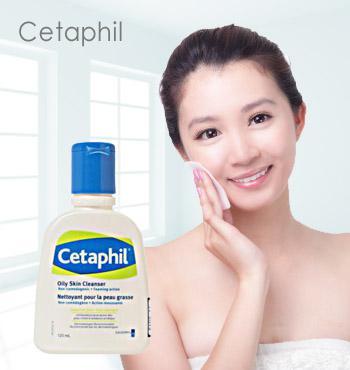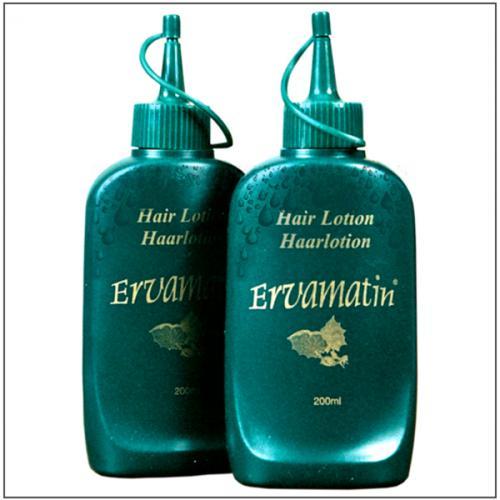The first image is the image on the left, the second image is the image on the right. Assess this claim about the two images: "All of the bottles in the images are green.". Correct or not? Answer yes or no. No. The first image is the image on the left, the second image is the image on the right. Given the left and right images, does the statement "A female has her hand touching her face, and an upright bottle overlaps the image." hold true? Answer yes or no. Yes. 